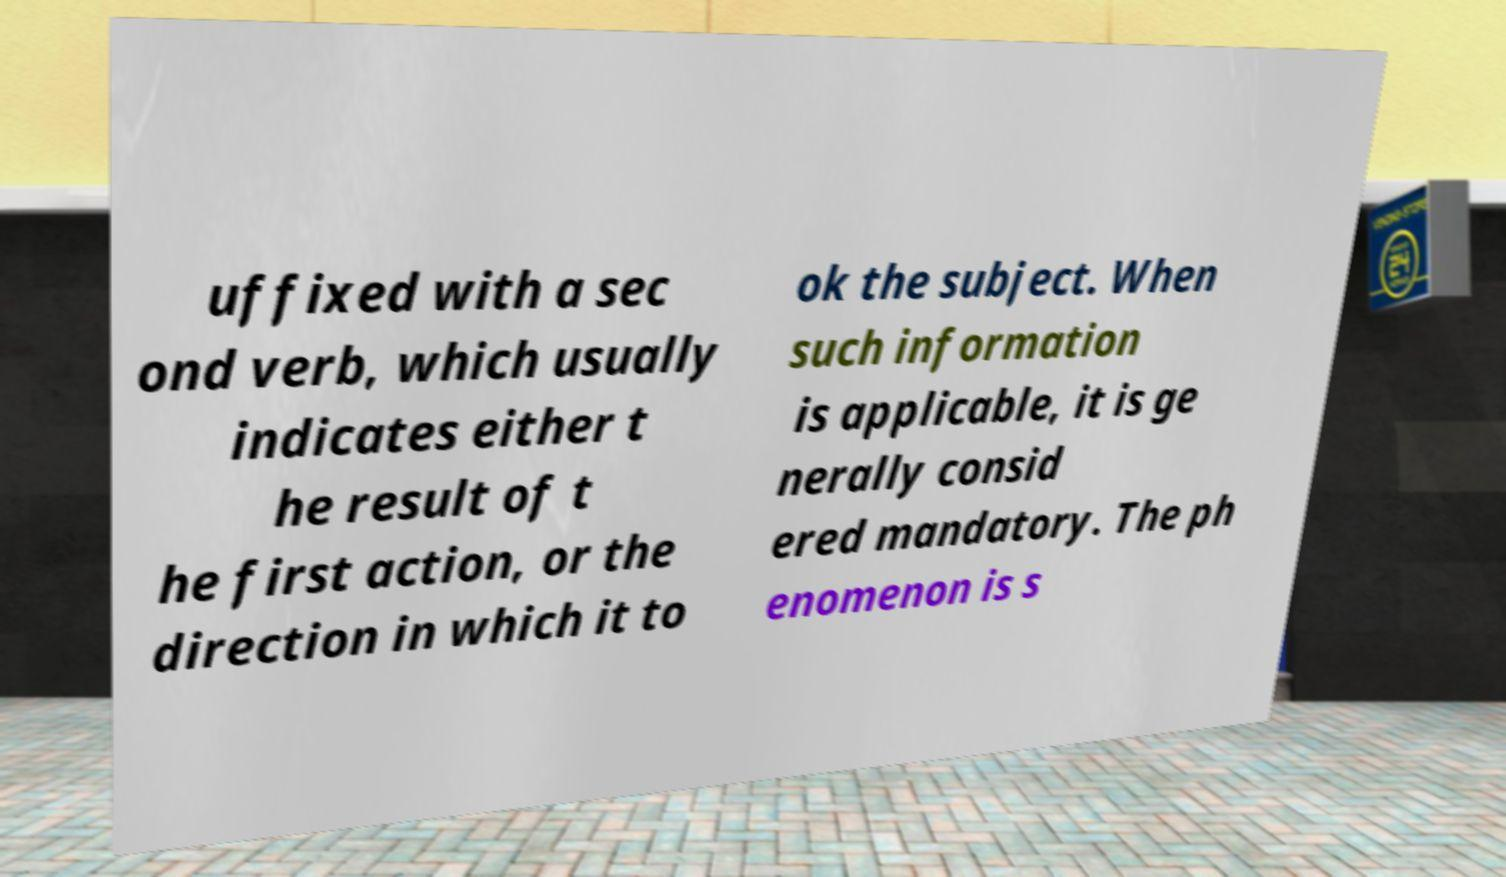There's text embedded in this image that I need extracted. Can you transcribe it verbatim? uffixed with a sec ond verb, which usually indicates either t he result of t he first action, or the direction in which it to ok the subject. When such information is applicable, it is ge nerally consid ered mandatory. The ph enomenon is s 